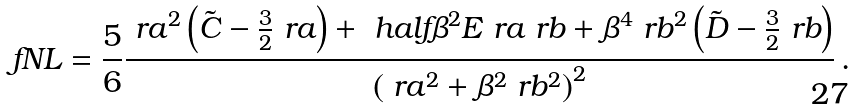<formula> <loc_0><loc_0><loc_500><loc_500>\ f N L = \frac { 5 } { 6 } \frac { \ r a ^ { 2 } \left ( \tilde { C } - \frac { 3 } { 2 } \ r a \right ) + \ h a l f \beta ^ { 2 } E \ r a \ r b + \beta ^ { 4 } \ r b ^ { 2 } \left ( \tilde { D } - \frac { 3 } { 2 } \ r b \right ) } { \left ( \ r a ^ { 2 } + \beta ^ { 2 } \ r b ^ { 2 } \right ) ^ { 2 } } \, .</formula> 